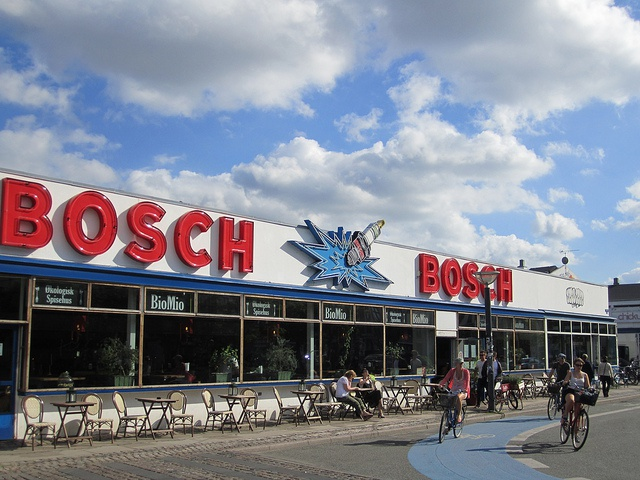Describe the objects in this image and their specific colors. I can see chair in darkgray, gray, black, and beige tones, bicycle in darkgray, black, and gray tones, chair in darkgray, gray, tan, and black tones, bicycle in darkgray, black, and gray tones, and people in darkgray, black, and gray tones in this image. 